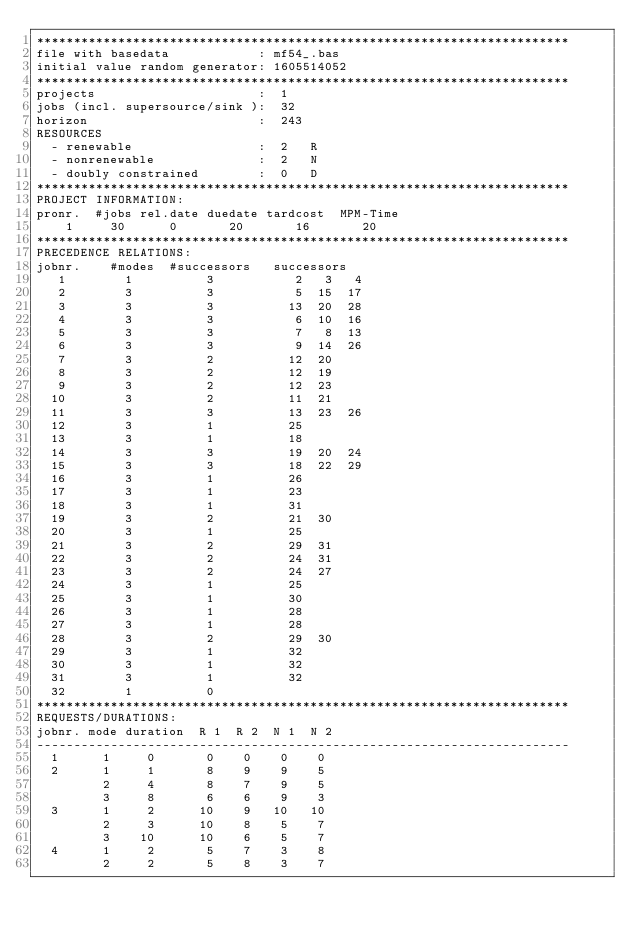Convert code to text. <code><loc_0><loc_0><loc_500><loc_500><_ObjectiveC_>************************************************************************
file with basedata            : mf54_.bas
initial value random generator: 1605514052
************************************************************************
projects                      :  1
jobs (incl. supersource/sink ):  32
horizon                       :  243
RESOURCES
  - renewable                 :  2   R
  - nonrenewable              :  2   N
  - doubly constrained        :  0   D
************************************************************************
PROJECT INFORMATION:
pronr.  #jobs rel.date duedate tardcost  MPM-Time
    1     30      0       20       16       20
************************************************************************
PRECEDENCE RELATIONS:
jobnr.    #modes  #successors   successors
   1        1          3           2   3   4
   2        3          3           5  15  17
   3        3          3          13  20  28
   4        3          3           6  10  16
   5        3          3           7   8  13
   6        3          3           9  14  26
   7        3          2          12  20
   8        3          2          12  19
   9        3          2          12  23
  10        3          2          11  21
  11        3          3          13  23  26
  12        3          1          25
  13        3          1          18
  14        3          3          19  20  24
  15        3          3          18  22  29
  16        3          1          26
  17        3          1          23
  18        3          1          31
  19        3          2          21  30
  20        3          1          25
  21        3          2          29  31
  22        3          2          24  31
  23        3          2          24  27
  24        3          1          25
  25        3          1          30
  26        3          1          28
  27        3          1          28
  28        3          2          29  30
  29        3          1          32
  30        3          1          32
  31        3          1          32
  32        1          0        
************************************************************************
REQUESTS/DURATIONS:
jobnr. mode duration  R 1  R 2  N 1  N 2
------------------------------------------------------------------------
  1      1     0       0    0    0    0
  2      1     1       8    9    9    5
         2     4       8    7    9    5
         3     8       6    6    9    3
  3      1     2      10    9   10   10
         2     3      10    8    5    7
         3    10      10    6    5    7
  4      1     2       5    7    3    8
         2     2       5    8    3    7</code> 